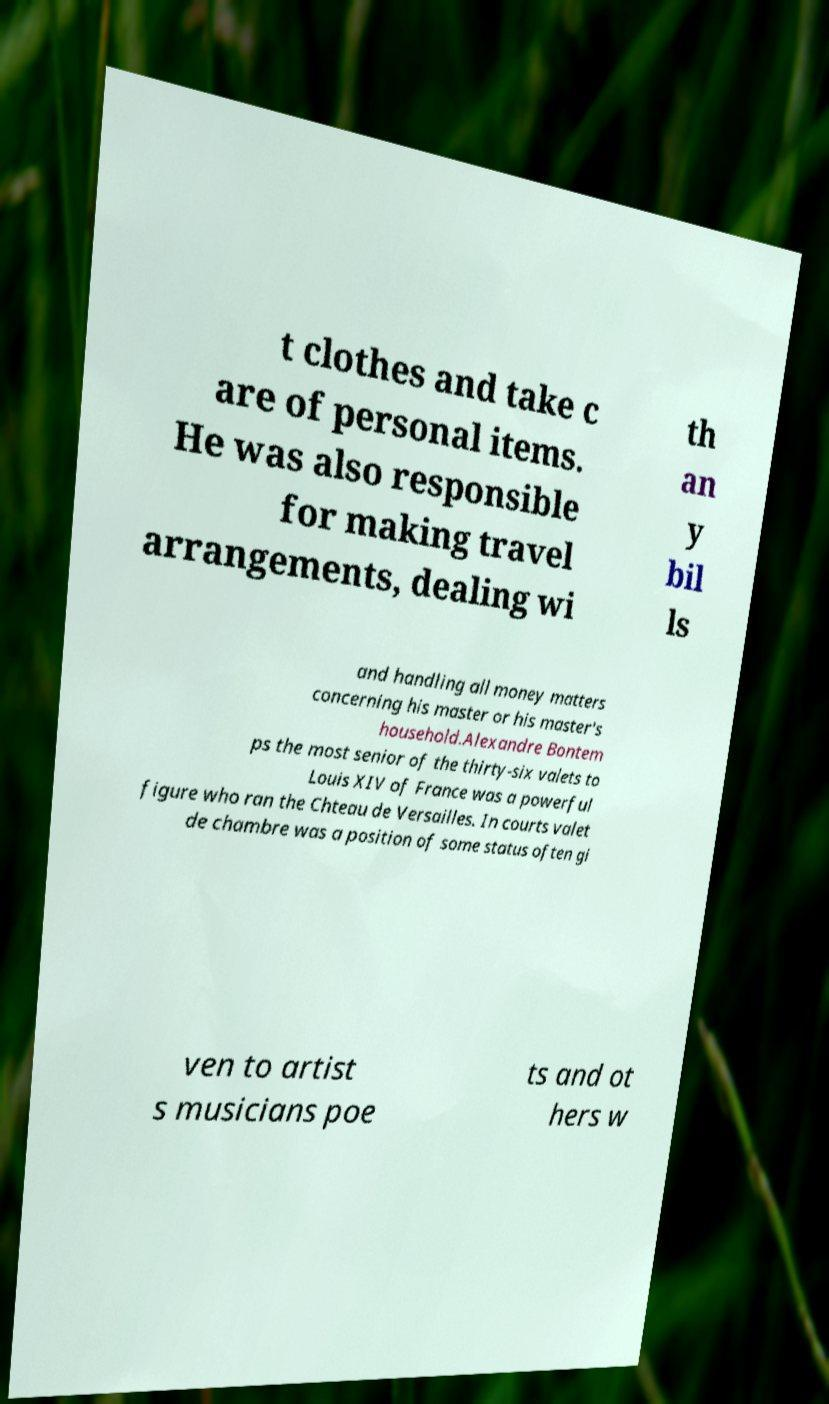Can you accurately transcribe the text from the provided image for me? t clothes and take c are of personal items. He was also responsible for making travel arrangements, dealing wi th an y bil ls and handling all money matters concerning his master or his master's household.Alexandre Bontem ps the most senior of the thirty-six valets to Louis XIV of France was a powerful figure who ran the Chteau de Versailles. In courts valet de chambre was a position of some status often gi ven to artist s musicians poe ts and ot hers w 